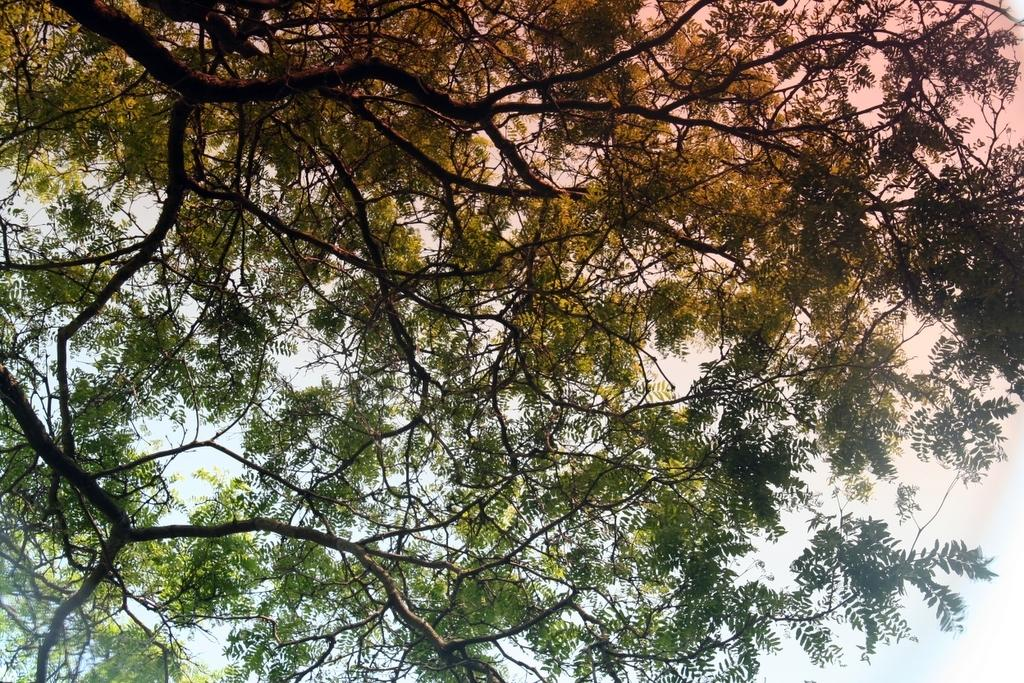What type of vegetation can be seen in the image? There are trees in the image. What part of the natural environment is visible in the image? The sky is visible in the image. What type of coat is hanging on the tree in the image? There is no coat present in the image; it only features trees and the sky. How many pickles can be seen growing on the trees in the image? There are no pickles present in the image, as trees typically do not grow pickles. 